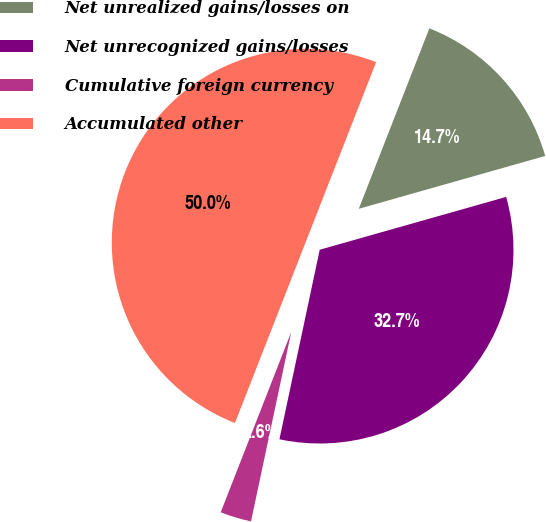Convert chart. <chart><loc_0><loc_0><loc_500><loc_500><pie_chart><fcel>Net unrealized gains/losses on<fcel>Net unrecognized gains/losses<fcel>Cumulative foreign currency<fcel>Accumulated other<nl><fcel>14.67%<fcel>32.73%<fcel>2.6%<fcel>50.0%<nl></chart> 